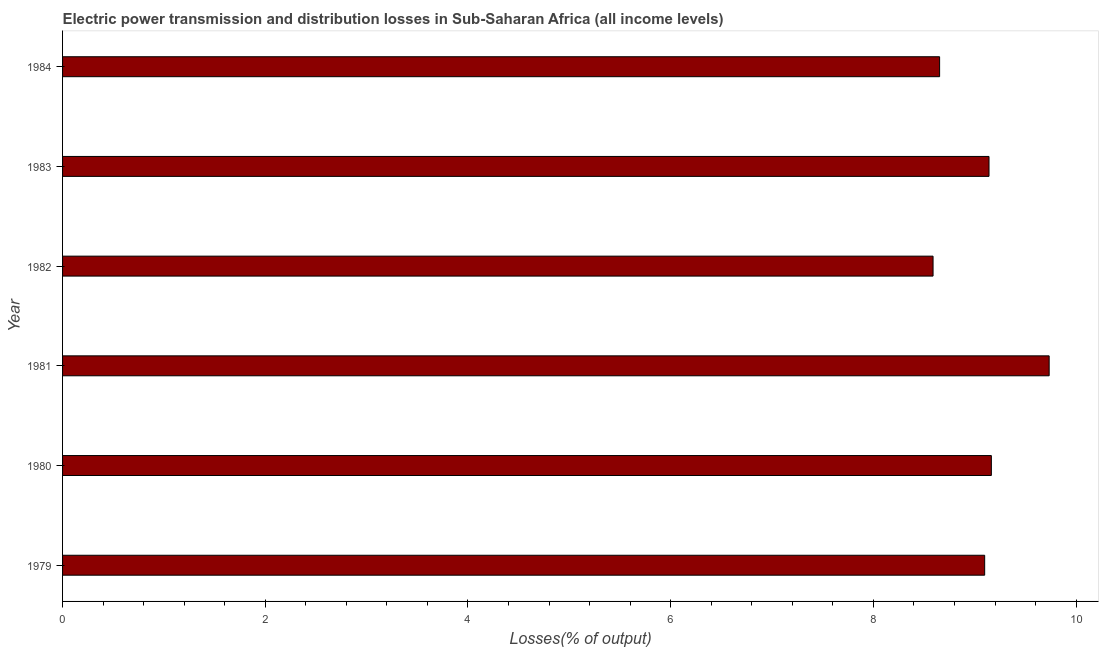Does the graph contain any zero values?
Offer a very short reply. No. Does the graph contain grids?
Your answer should be very brief. No. What is the title of the graph?
Your answer should be compact. Electric power transmission and distribution losses in Sub-Saharan Africa (all income levels). What is the label or title of the X-axis?
Your response must be concise. Losses(% of output). What is the electric power transmission and distribution losses in 1980?
Give a very brief answer. 9.16. Across all years, what is the maximum electric power transmission and distribution losses?
Your answer should be compact. 9.73. Across all years, what is the minimum electric power transmission and distribution losses?
Give a very brief answer. 8.59. What is the sum of the electric power transmission and distribution losses?
Give a very brief answer. 54.38. What is the difference between the electric power transmission and distribution losses in 1979 and 1984?
Offer a very short reply. 0.45. What is the average electric power transmission and distribution losses per year?
Keep it short and to the point. 9.06. What is the median electric power transmission and distribution losses?
Offer a very short reply. 9.12. Do a majority of the years between 1983 and 1981 (inclusive) have electric power transmission and distribution losses greater than 4 %?
Ensure brevity in your answer.  Yes. What is the ratio of the electric power transmission and distribution losses in 1981 to that in 1984?
Your answer should be very brief. 1.12. Is the electric power transmission and distribution losses in 1981 less than that in 1984?
Offer a very short reply. No. Is the difference between the electric power transmission and distribution losses in 1979 and 1984 greater than the difference between any two years?
Provide a short and direct response. No. What is the difference between the highest and the second highest electric power transmission and distribution losses?
Your answer should be compact. 0.57. Is the sum of the electric power transmission and distribution losses in 1980 and 1983 greater than the maximum electric power transmission and distribution losses across all years?
Make the answer very short. Yes. What is the difference between the highest and the lowest electric power transmission and distribution losses?
Your answer should be very brief. 1.15. In how many years, is the electric power transmission and distribution losses greater than the average electric power transmission and distribution losses taken over all years?
Provide a succinct answer. 4. Are all the bars in the graph horizontal?
Your answer should be compact. Yes. What is the Losses(% of output) of 1979?
Provide a succinct answer. 9.1. What is the Losses(% of output) in 1980?
Your answer should be very brief. 9.16. What is the Losses(% of output) of 1981?
Offer a terse response. 9.73. What is the Losses(% of output) of 1982?
Ensure brevity in your answer.  8.59. What is the Losses(% of output) in 1983?
Provide a succinct answer. 9.14. What is the Losses(% of output) in 1984?
Your response must be concise. 8.65. What is the difference between the Losses(% of output) in 1979 and 1980?
Your answer should be very brief. -0.07. What is the difference between the Losses(% of output) in 1979 and 1981?
Your answer should be very brief. -0.64. What is the difference between the Losses(% of output) in 1979 and 1982?
Keep it short and to the point. 0.51. What is the difference between the Losses(% of output) in 1979 and 1983?
Offer a terse response. -0.04. What is the difference between the Losses(% of output) in 1979 and 1984?
Make the answer very short. 0.44. What is the difference between the Losses(% of output) in 1980 and 1981?
Ensure brevity in your answer.  -0.57. What is the difference between the Losses(% of output) in 1980 and 1982?
Your response must be concise. 0.58. What is the difference between the Losses(% of output) in 1980 and 1983?
Give a very brief answer. 0.02. What is the difference between the Losses(% of output) in 1980 and 1984?
Provide a short and direct response. 0.51. What is the difference between the Losses(% of output) in 1981 and 1982?
Offer a terse response. 1.15. What is the difference between the Losses(% of output) in 1981 and 1983?
Keep it short and to the point. 0.59. What is the difference between the Losses(% of output) in 1981 and 1984?
Ensure brevity in your answer.  1.08. What is the difference between the Losses(% of output) in 1982 and 1983?
Keep it short and to the point. -0.55. What is the difference between the Losses(% of output) in 1982 and 1984?
Offer a very short reply. -0.06. What is the difference between the Losses(% of output) in 1983 and 1984?
Your answer should be very brief. 0.49. What is the ratio of the Losses(% of output) in 1979 to that in 1980?
Offer a very short reply. 0.99. What is the ratio of the Losses(% of output) in 1979 to that in 1981?
Make the answer very short. 0.94. What is the ratio of the Losses(% of output) in 1979 to that in 1982?
Your answer should be compact. 1.06. What is the ratio of the Losses(% of output) in 1979 to that in 1983?
Make the answer very short. 0.99. What is the ratio of the Losses(% of output) in 1979 to that in 1984?
Your response must be concise. 1.05. What is the ratio of the Losses(% of output) in 1980 to that in 1981?
Make the answer very short. 0.94. What is the ratio of the Losses(% of output) in 1980 to that in 1982?
Provide a succinct answer. 1.07. What is the ratio of the Losses(% of output) in 1980 to that in 1984?
Your answer should be compact. 1.06. What is the ratio of the Losses(% of output) in 1981 to that in 1982?
Ensure brevity in your answer.  1.13. What is the ratio of the Losses(% of output) in 1981 to that in 1983?
Your answer should be very brief. 1.06. What is the ratio of the Losses(% of output) in 1982 to that in 1983?
Offer a terse response. 0.94. What is the ratio of the Losses(% of output) in 1982 to that in 1984?
Offer a very short reply. 0.99. What is the ratio of the Losses(% of output) in 1983 to that in 1984?
Give a very brief answer. 1.06. 